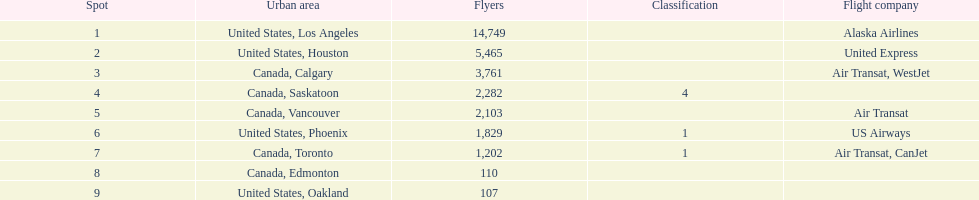Was los angeles or houston the busiest international route at manzanillo international airport in 2013? Los Angeles. 